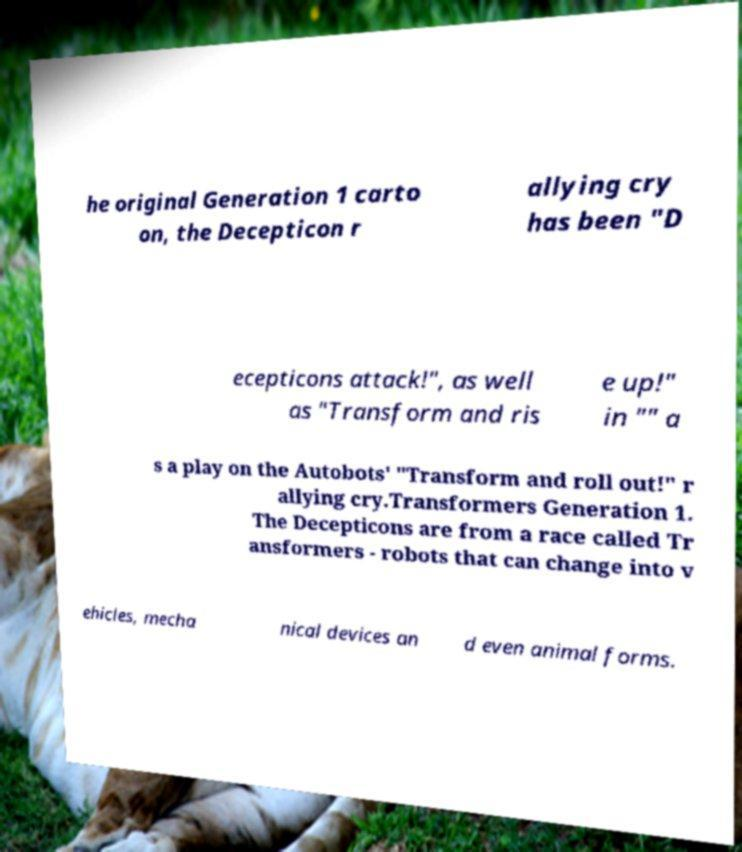Could you extract and type out the text from this image? he original Generation 1 carto on, the Decepticon r allying cry has been "D ecepticons attack!", as well as "Transform and ris e up!" in "" a s a play on the Autobots' "Transform and roll out!" r allying cry.Transformers Generation 1. The Decepticons are from a race called Tr ansformers - robots that can change into v ehicles, mecha nical devices an d even animal forms. 